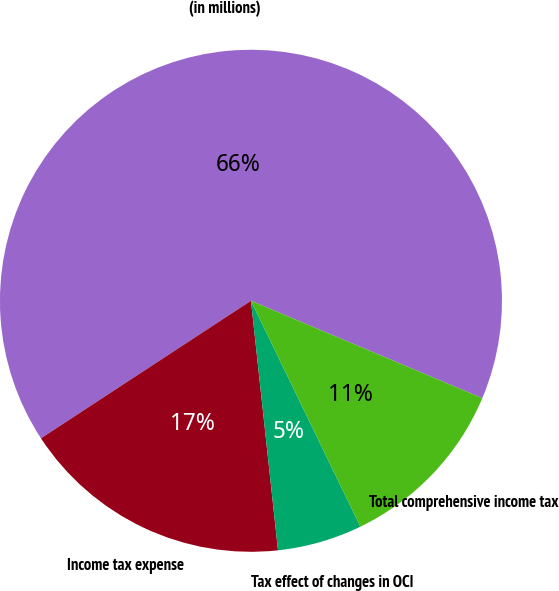Convert chart. <chart><loc_0><loc_0><loc_500><loc_500><pie_chart><fcel>(in millions)<fcel>Income tax expense<fcel>Tax effect of changes in OCI<fcel>Total comprehensive income tax<nl><fcel>65.57%<fcel>17.49%<fcel>5.46%<fcel>11.48%<nl></chart> 